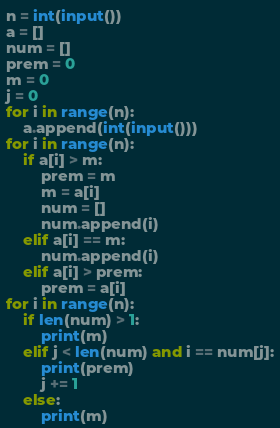Convert code to text. <code><loc_0><loc_0><loc_500><loc_500><_Python_>n = int(input())
a = []
num = []
prem = 0
m = 0
j = 0
for i in range(n):
    a.append(int(input()))
for i in range(n):
    if a[i] > m:
        prem = m
        m = a[i]
        num = []
        num.append(i)
    elif a[i] == m:
        num.append(i)
    elif a[i] > prem:
        prem = a[i]
for i in range(n):
    if len(num) > 1:
        print(m)
    elif j < len(num) and i == num[j]:
        print(prem)
        j += 1
    else:
        print(m)
</code> 